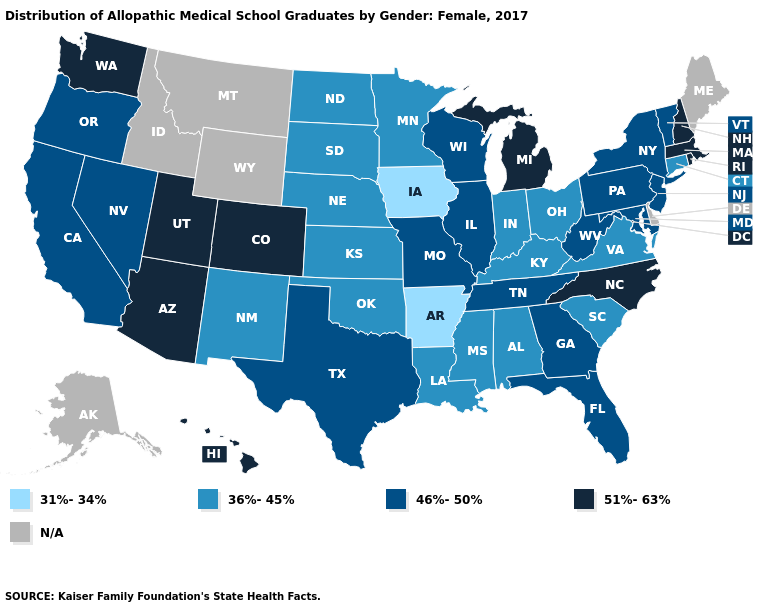What is the value of Indiana?
Write a very short answer. 36%-45%. Name the states that have a value in the range 51%-63%?
Answer briefly. Arizona, Colorado, Hawaii, Massachusetts, Michigan, New Hampshire, North Carolina, Rhode Island, Utah, Washington. Name the states that have a value in the range 31%-34%?
Quick response, please. Arkansas, Iowa. Among the states that border Minnesota , which have the highest value?
Answer briefly. Wisconsin. Name the states that have a value in the range 46%-50%?
Write a very short answer. California, Florida, Georgia, Illinois, Maryland, Missouri, Nevada, New Jersey, New York, Oregon, Pennsylvania, Tennessee, Texas, Vermont, West Virginia, Wisconsin. What is the highest value in the Northeast ?
Keep it brief. 51%-63%. Among the states that border Kentucky , which have the lowest value?
Keep it brief. Indiana, Ohio, Virginia. Among the states that border California , which have the highest value?
Answer briefly. Arizona. Name the states that have a value in the range N/A?
Short answer required. Alaska, Delaware, Idaho, Maine, Montana, Wyoming. Name the states that have a value in the range 31%-34%?
Short answer required. Arkansas, Iowa. What is the highest value in the USA?
Keep it brief. 51%-63%. What is the highest value in the MidWest ?
Quick response, please. 51%-63%. What is the value of Washington?
Quick response, please. 51%-63%. What is the value of Missouri?
Keep it brief. 46%-50%. Does Connecticut have the lowest value in the Northeast?
Write a very short answer. Yes. 